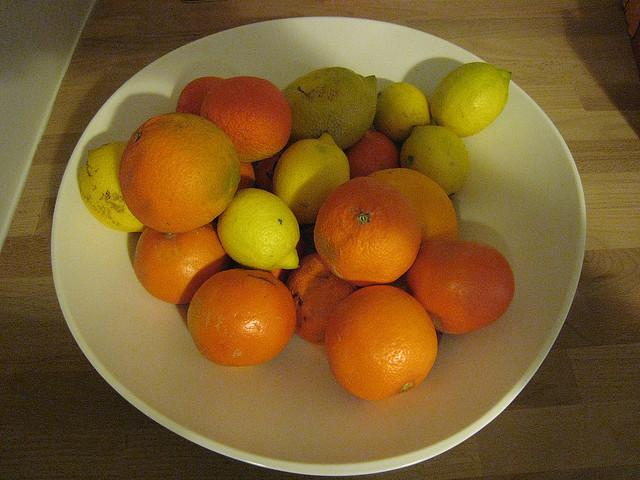Where do lemons originally come from? Please explain your reasoning. unknown. They come from ethipoia. 